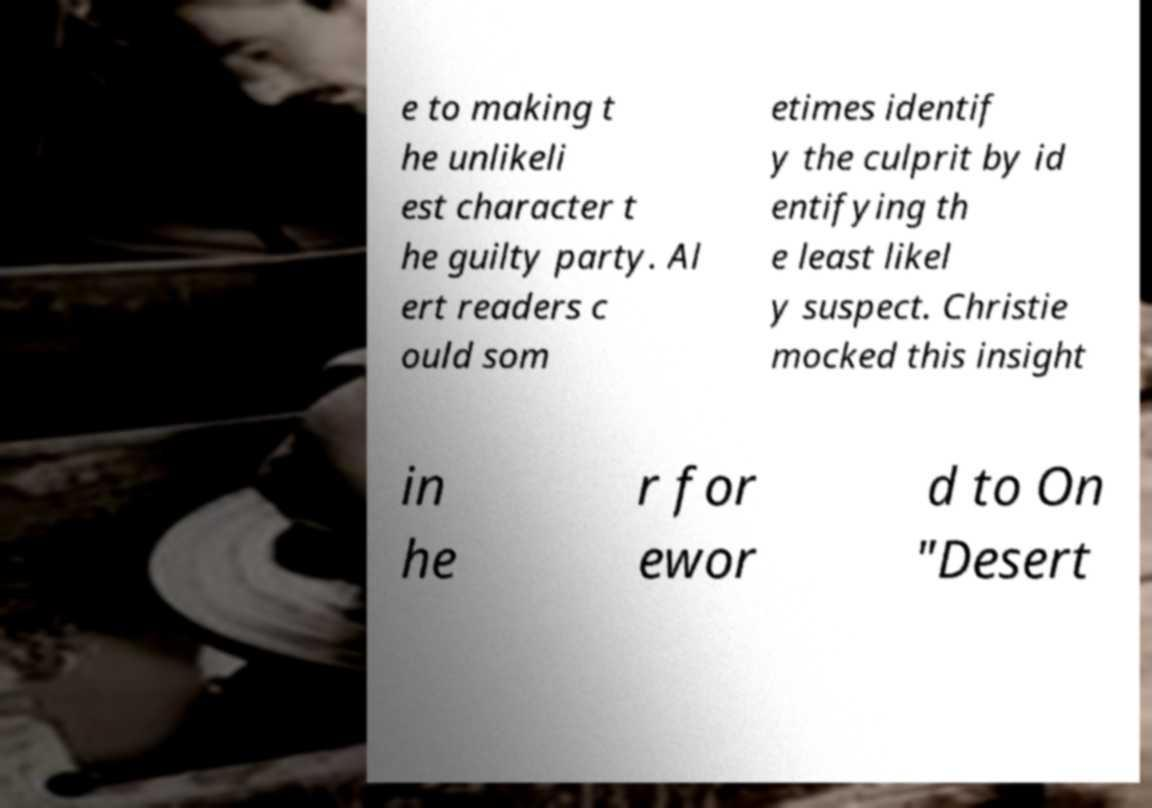Could you extract and type out the text from this image? e to making t he unlikeli est character t he guilty party. Al ert readers c ould som etimes identif y the culprit by id entifying th e least likel y suspect. Christie mocked this insight in he r for ewor d to On "Desert 